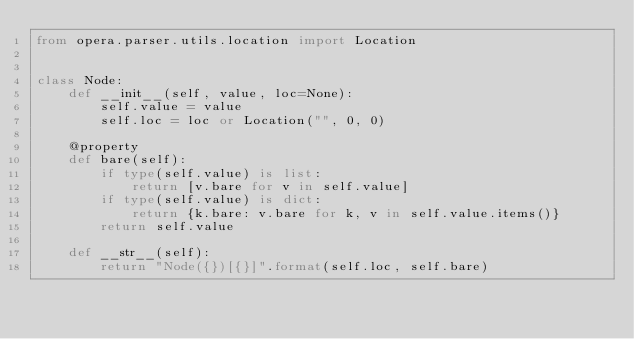<code> <loc_0><loc_0><loc_500><loc_500><_Python_>from opera.parser.utils.location import Location


class Node:
    def __init__(self, value, loc=None):
        self.value = value
        self.loc = loc or Location("", 0, 0)

    @property
    def bare(self):
        if type(self.value) is list:
            return [v.bare for v in self.value]
        if type(self.value) is dict:
            return {k.bare: v.bare for k, v in self.value.items()}
        return self.value

    def __str__(self):
        return "Node({})[{}]".format(self.loc, self.bare)
</code> 